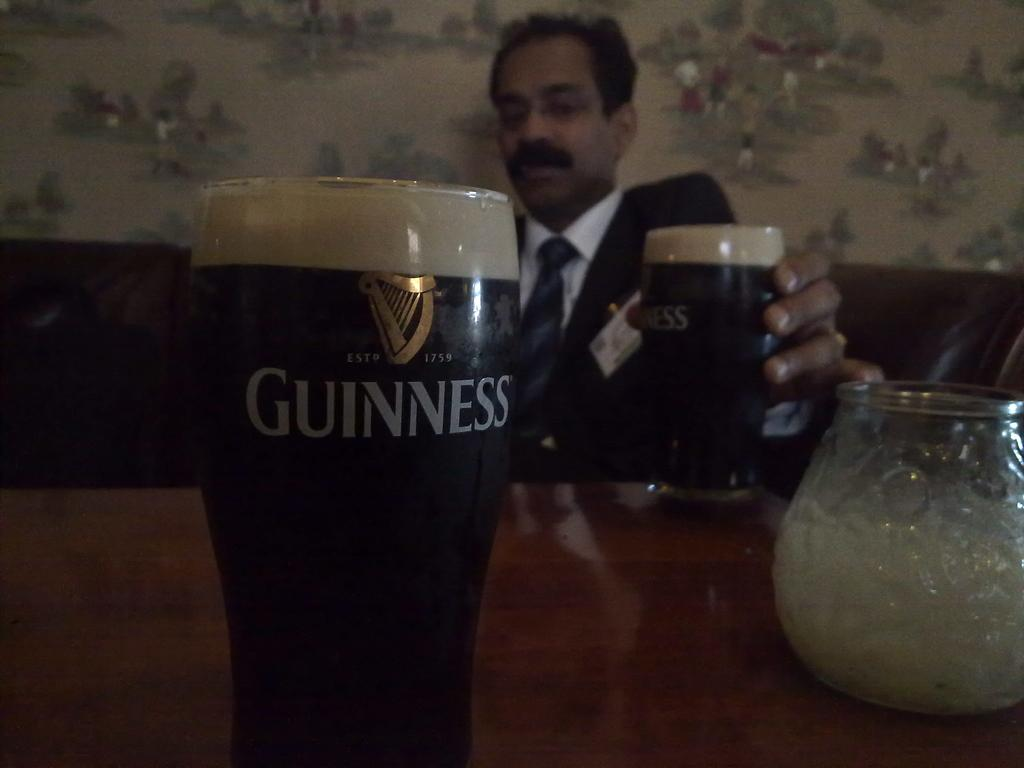What objects are on the table in the image? There are glasses and a glass jar on the table in the image. What is the man in the image doing? The man is seated and holding a glass in his hand. Can you describe the man's position in relation to the table? The man is seated at the table. What is the acoustics like in the room where the man is seated? The provided facts do not give any information about the acoustics in the room, so it cannot be determined from the image. 